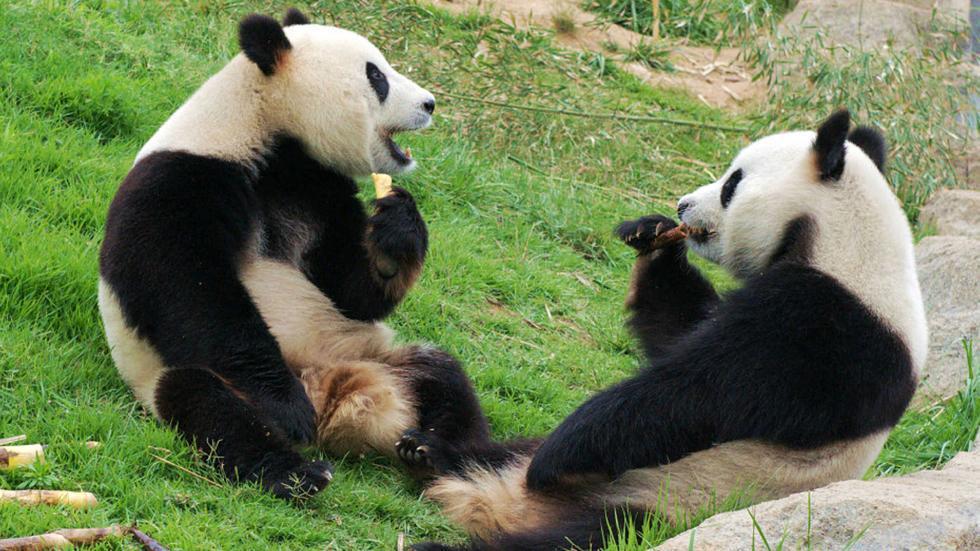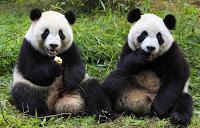The first image is the image on the left, the second image is the image on the right. Given the left and right images, does the statement "Both images in the pair have two pandas." hold true? Answer yes or no. Yes. The first image is the image on the left, the second image is the image on the right. Given the left and right images, does the statement "One image shows pandas sitting side by side, each with a paw raised to its mouth, and the other image shows two pandas who are looking toward one another." hold true? Answer yes or no. Yes. 